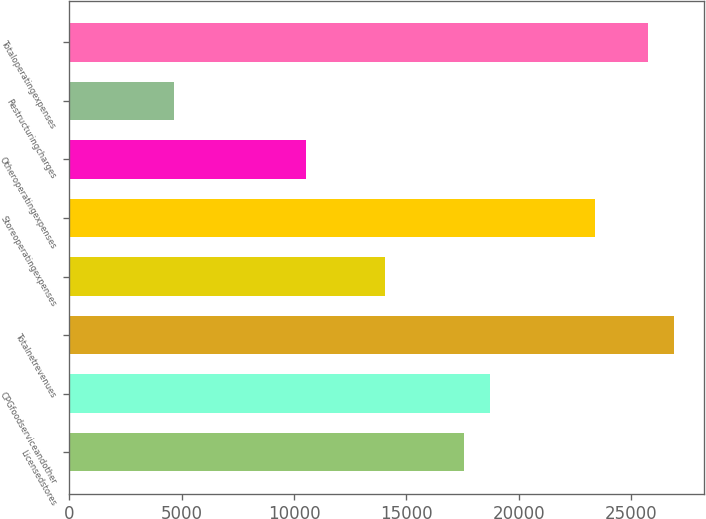<chart> <loc_0><loc_0><loc_500><loc_500><bar_chart><fcel>Licensedstores<fcel>CPGfoodserviceandother<fcel>Totalnetrevenues<fcel>Unnamed: 3<fcel>Storeoperatingexpenses<fcel>Otheroperatingexpenses<fcel>Restructuringcharges<fcel>Totaloperatingexpenses<nl><fcel>17550.3<fcel>18720.2<fcel>26910.1<fcel>14040.3<fcel>23400.2<fcel>10530.4<fcel>4680.48<fcel>25740.1<nl></chart> 